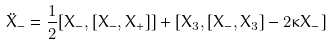<formula> <loc_0><loc_0><loc_500><loc_500>\ddot { X } _ { - } = \frac { 1 } { 2 } [ X _ { - } , [ X _ { - } , X _ { + } ] ] + [ X _ { 3 } , [ X _ { - } , X _ { 3 } ] - 2 \kappa X _ { - } ]</formula> 